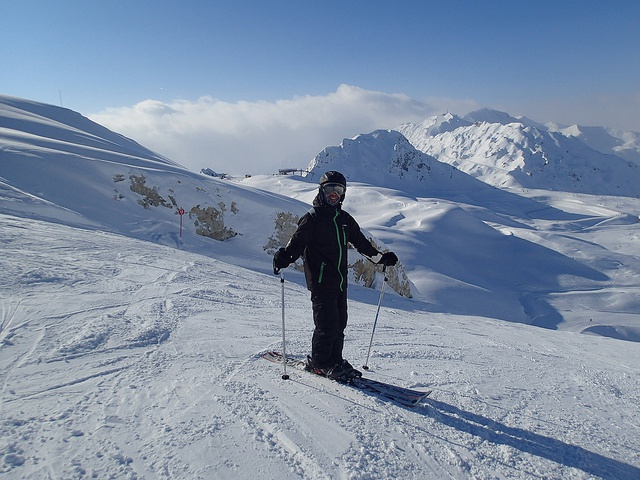Describe the objects in this image and their specific colors. I can see people in darkgray, black, and gray tones and skis in darkgray, navy, black, darkblue, and gray tones in this image. 